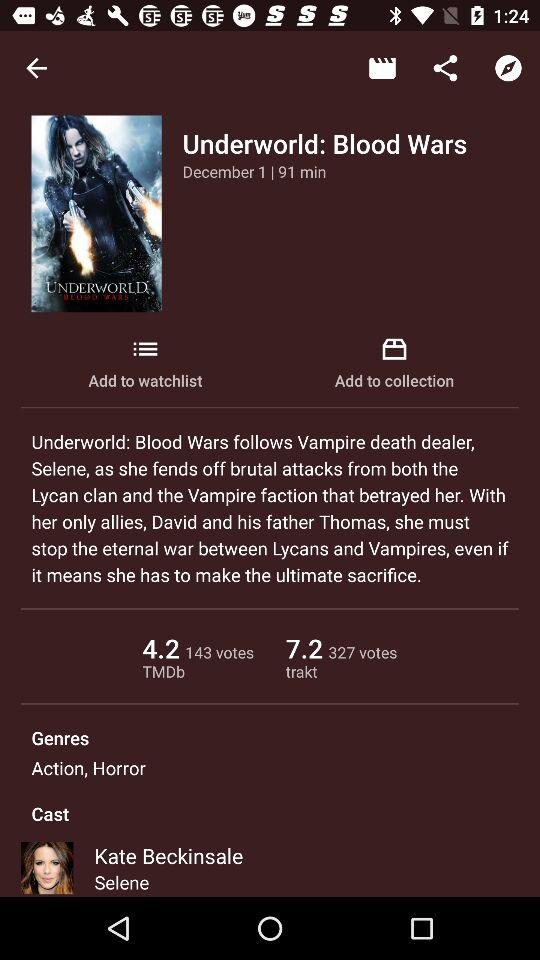What are the genres of the movie? The genres of the movie are action and horror. 